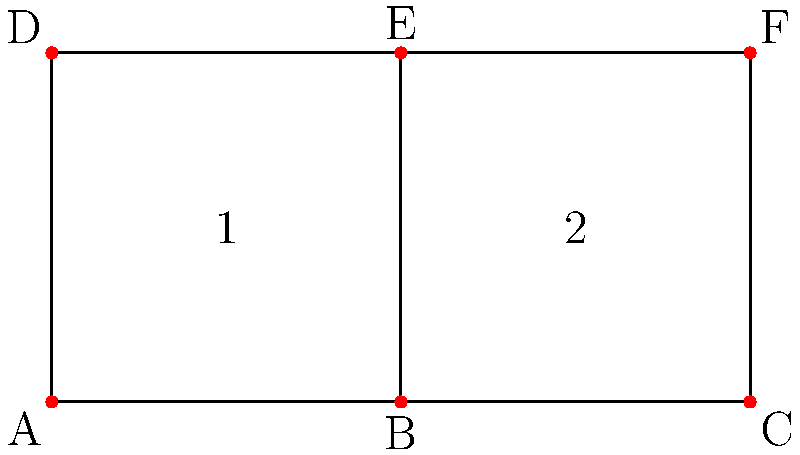As a content writer, you're designing a website structure represented by a simplicial complex. The diagram shows the content hierarchy, where vertices represent pages, edges represent links, and faces represent content clusters. Calculate the Euler characteristic of this structure and explain how it relates to the website's navigability. To solve this problem, we'll follow these steps:

1. Count the number of vertices (V), edges (E), and faces (F) in the simplicial complex:
   Vertices (V) = 6 (A, B, C, D, E, F)
   Edges (E) = 7 (AB, BC, CF, FE, ED, DA, BE)
   Faces (F) = 2 (ABED, BCEF)

2. Calculate the Euler characteristic using the formula:
   $$ \chi = V - E + F $$
   
   Substituting the values:
   $$ \chi = 6 - 7 + 2 = 1 $$

3. Interpret the result:
   The Euler characteristic of 1 indicates that this structure is topologically equivalent to a disk. In terms of website structure:
   
   a) The positive Euler characteristic suggests a well-connected layout with no "holes" in the navigation.
   
   b) The value of 1 implies a single, cohesive structure without disconnected components.
   
   c) This structure allows for efficient navigation, as all pages are accessible through multiple paths.

4. Relation to content writing and navigability:
   - The simplicial complex representation helps visualize how content clusters (faces) are formed by interlinked pages.
   - The structure ensures that related content is grouped together, making it easier for users to find relevant information.
   - The multiple paths between pages (represented by the edges) allow for creating compelling narratives that guide users through the content.
   - The Euler characteristic of 1 suggests a balanced structure that is neither too simple (which would be less engaging) nor too complex (which could be confusing for users).

This topological approach to content structure can help content writers design more engaging and navigable websites, ensuring that the compelling text is supported by an equally compelling information architecture.
Answer: $\chi = 1$, indicating a well-connected, disk-like structure that supports engaging content navigation. 